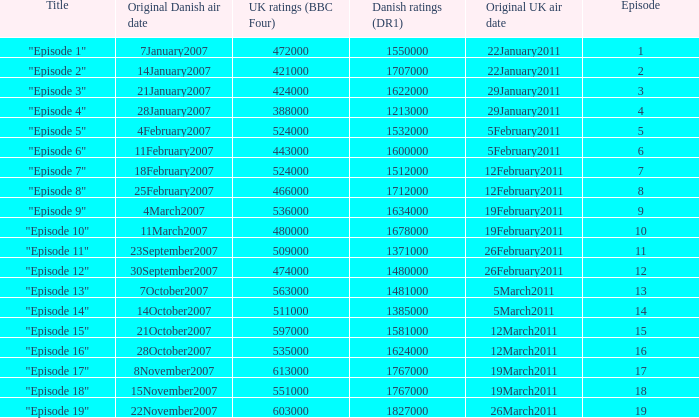What is the original Danish air date of "Episode 17"?  8November2007. 